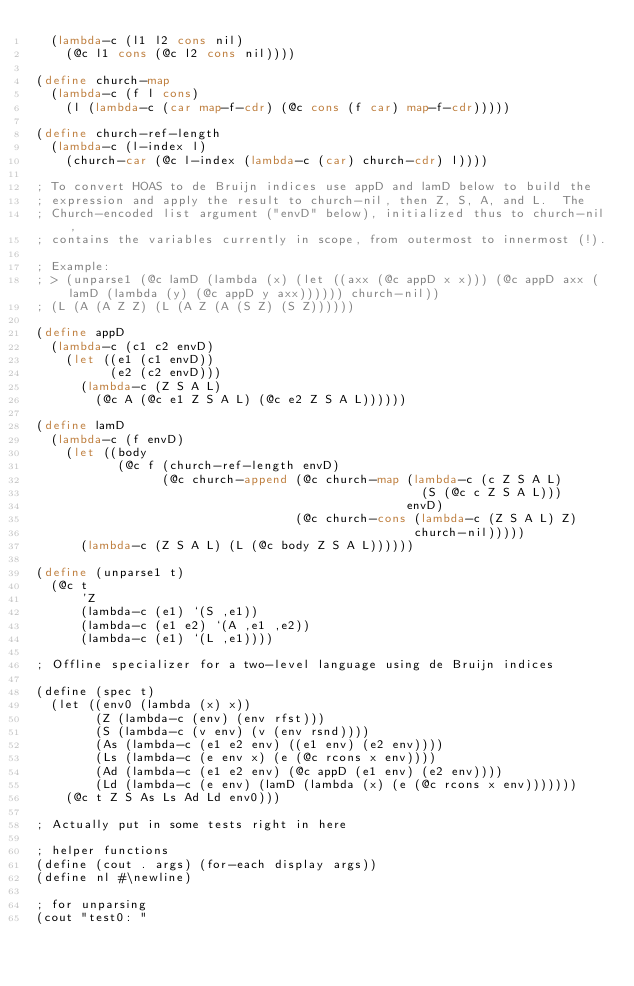Convert code to text. <code><loc_0><loc_0><loc_500><loc_500><_Scheme_>  (lambda-c (l1 l2 cons nil)
    (@c l1 cons (@c l2 cons nil))))

(define church-map
  (lambda-c (f l cons)
    (l (lambda-c (car map-f-cdr) (@c cons (f car) map-f-cdr)))))

(define church-ref-length
  (lambda-c (l-index l)
    (church-car (@c l-index (lambda-c (car) church-cdr) l))))

; To convert HOAS to de Bruijn indices use appD and lamD below to build the
; expression and apply the result to church-nil, then Z, S, A, and L.  The
; Church-encoded list argument ("envD" below), initialized thus to church-nil,
; contains the variables currently in scope, from outermost to innermost (!).

; Example:
; > (unparse1 (@c lamD (lambda (x) (let ((axx (@c appD x x))) (@c appD axx (lamD (lambda (y) (@c appD y axx)))))) church-nil))
; (L (A (A Z Z) (L (A Z (A (S Z) (S Z))))))

(define appD
  (lambda-c (c1 c2 envD)
    (let ((e1 (c1 envD))
          (e2 (c2 envD)))
      (lambda-c (Z S A L)
        (@c A (@c e1 Z S A L) (@c e2 Z S A L))))))

(define lamD
  (lambda-c (f envD)
    (let ((body
           (@c f (church-ref-length envD)
                 (@c church-append (@c church-map (lambda-c (c Z S A L)
                                                    (S (@c c Z S A L)))
                                                  envD)
                                   (@c church-cons (lambda-c (Z S A L) Z)
                                                   church-nil)))))
      (lambda-c (Z S A L) (L (@c body Z S A L))))))

(define (unparse1 t)
  (@c t
      'Z
      (lambda-c (e1) `(S ,e1))
      (lambda-c (e1 e2) `(A ,e1 ,e2))
      (lambda-c (e1) `(L ,e1))))

; Offline specializer for a two-level language using de Bruijn indices

(define (spec t)
  (let ((env0 (lambda (x) x))
        (Z (lambda-c (env) (env rfst)))
        (S (lambda-c (v env) (v (env rsnd))))
        (As (lambda-c (e1 e2 env) ((e1 env) (e2 env))))
        (Ls (lambda-c (e env x) (e (@c rcons x env))))
        (Ad (lambda-c (e1 e2 env) (@c appD (e1 env) (e2 env))))
        (Ld (lambda-c (e env) (lamD (lambda (x) (e (@c rcons x env)))))))
    (@c t Z S As Ls Ad Ld env0)))

; Actually put in some tests right in here

; helper functions
(define (cout . args) (for-each display args)) 
(define nl #\newline)

; for unparsing
(cout "test0: "</code> 